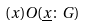Convert formula to latex. <formula><loc_0><loc_0><loc_500><loc_500>( x ) O ( \underline { x } \colon G )</formula> 